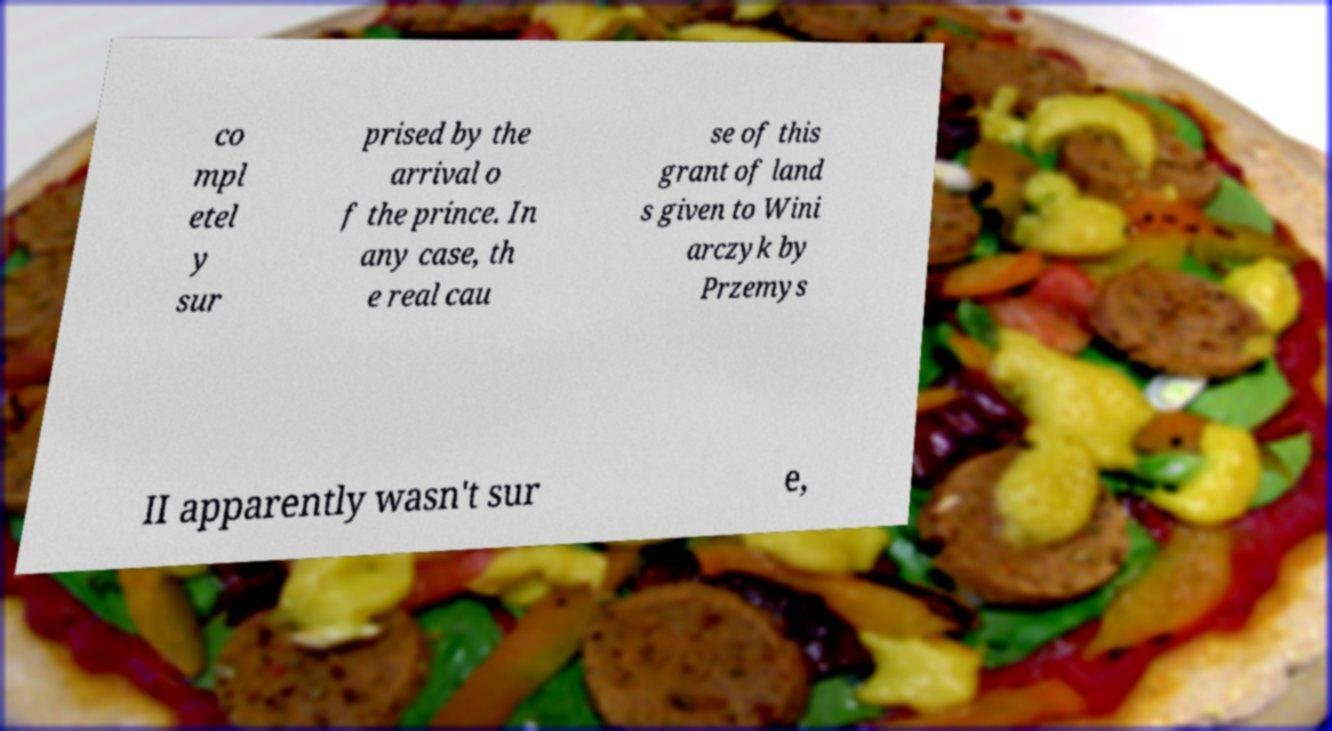Please identify and transcribe the text found in this image. co mpl etel y sur prised by the arrival o f the prince. In any case, th e real cau se of this grant of land s given to Wini arczyk by Przemys II apparently wasn't sur e, 